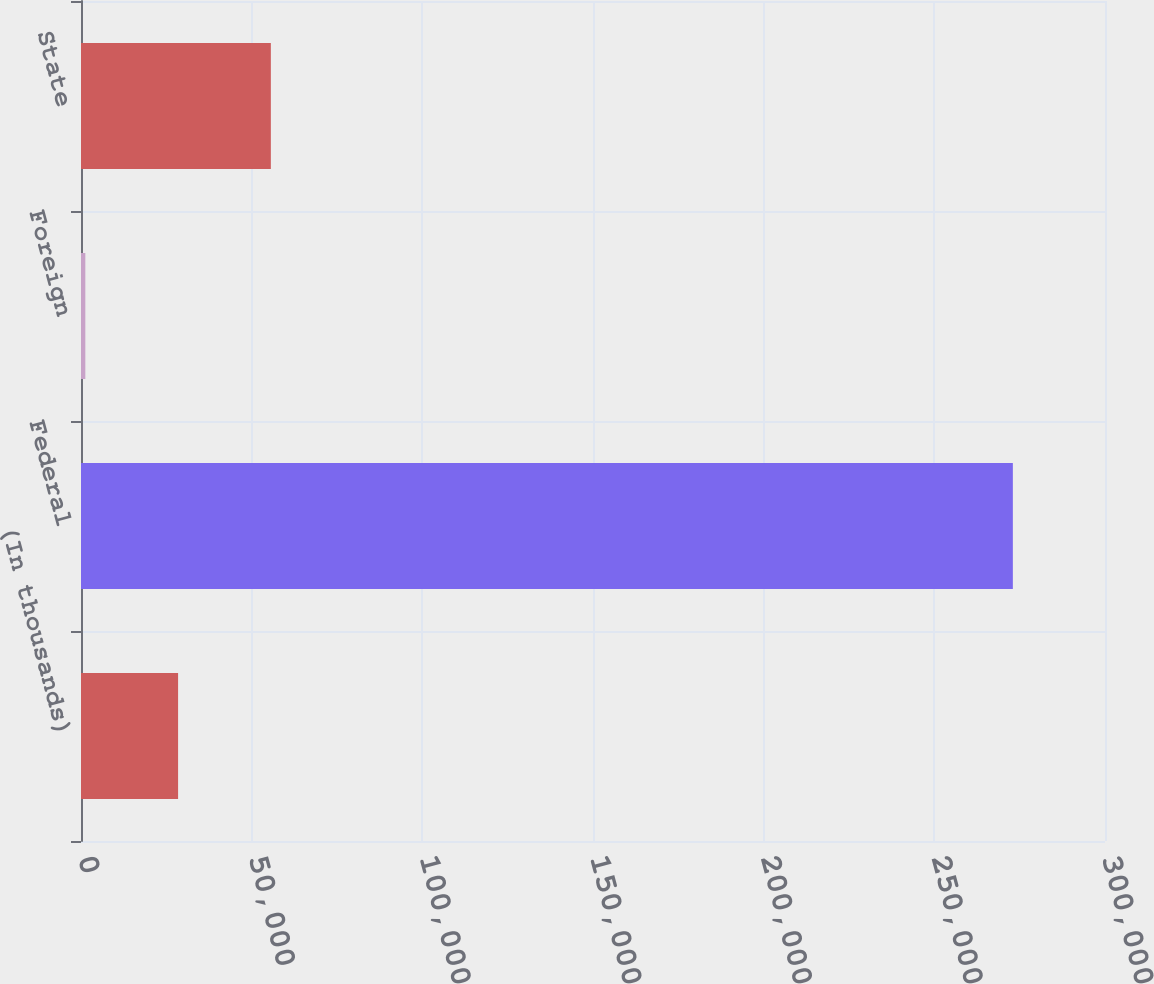Convert chart. <chart><loc_0><loc_0><loc_500><loc_500><bar_chart><fcel>(In thousands)<fcel>Federal<fcel>Foreign<fcel>State<nl><fcel>28442.6<fcel>273005<fcel>1269<fcel>55616.2<nl></chart> 